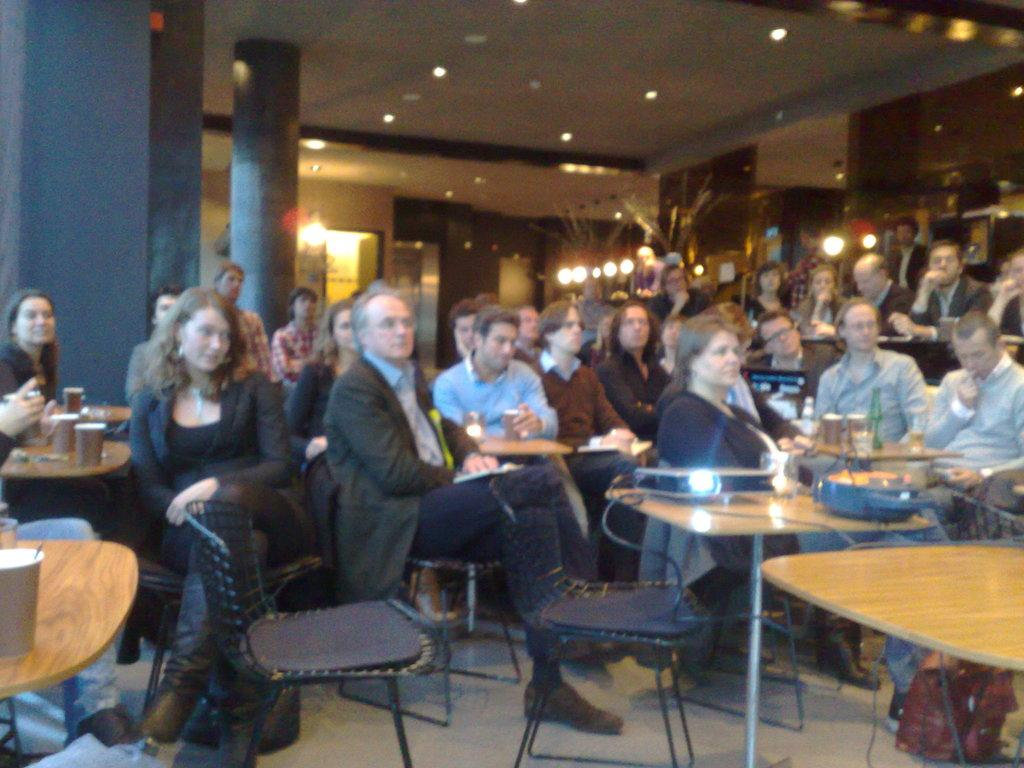How many people are in the image? There are many people in the image. What are the people doing in the image? The people are sitting on chairs. How are the chairs arranged in the image? The chairs are arranged around a table. What type of location might the image depict? The setting appears to be a hotel. What can be seen on the ceiling in the image? There are lights on the ceiling. What type of sticks are being used for pleasure in the image? There are no sticks or any indication of pleasure-related activities in the image. 